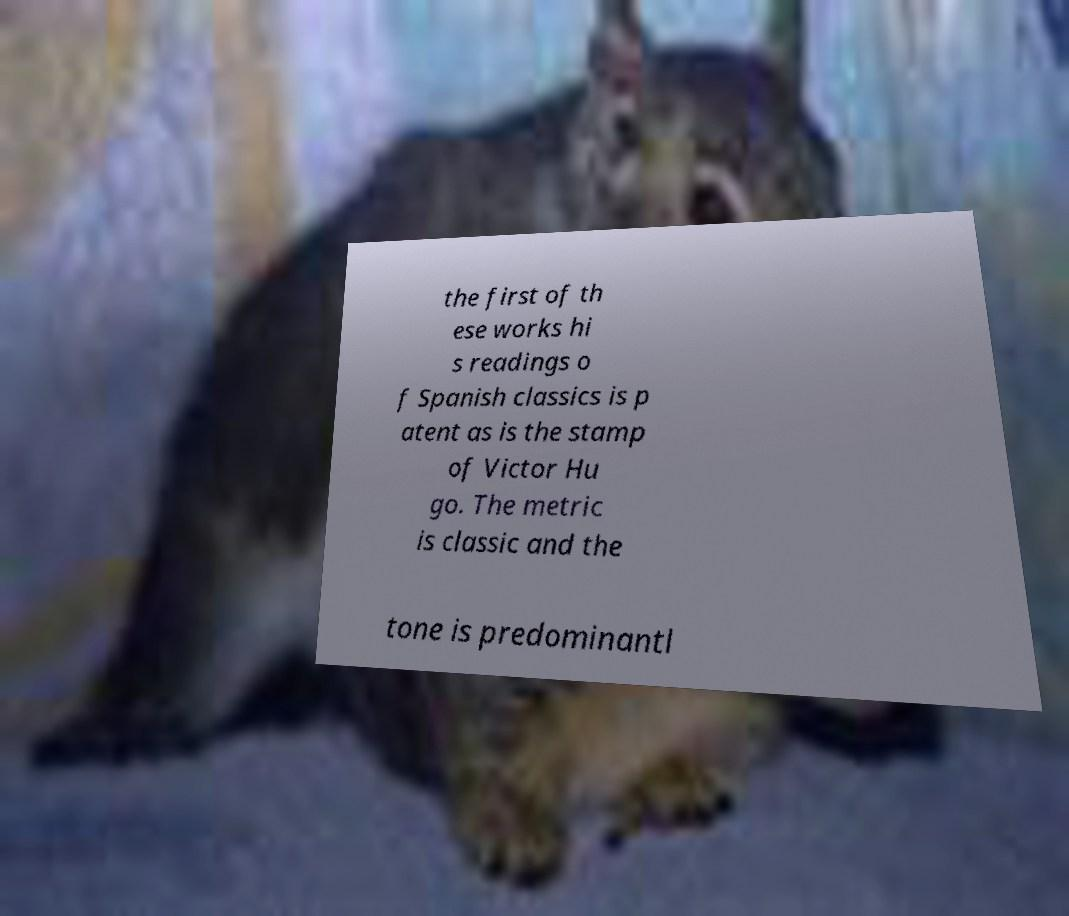Could you assist in decoding the text presented in this image and type it out clearly? the first of th ese works hi s readings o f Spanish classics is p atent as is the stamp of Victor Hu go. The metric is classic and the tone is predominantl 